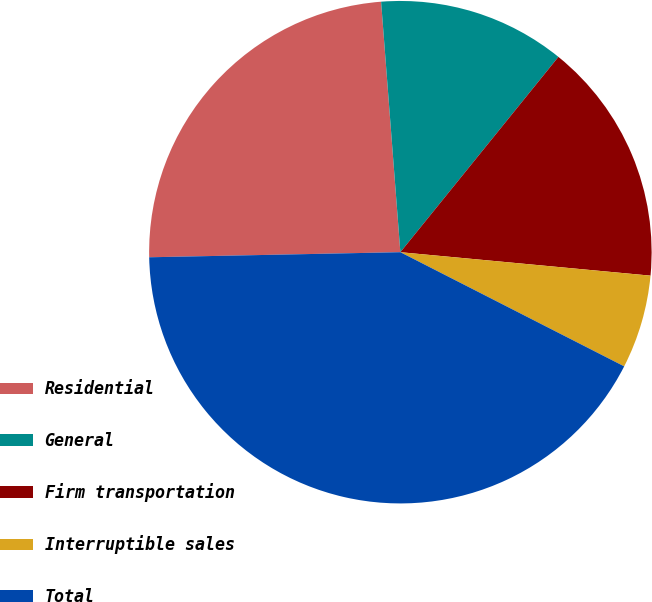Convert chart to OTSL. <chart><loc_0><loc_0><loc_500><loc_500><pie_chart><fcel>Residential<fcel>General<fcel>Firm transportation<fcel>Interruptible sales<fcel>Total<nl><fcel>24.1%<fcel>12.05%<fcel>15.66%<fcel>6.02%<fcel>42.17%<nl></chart> 